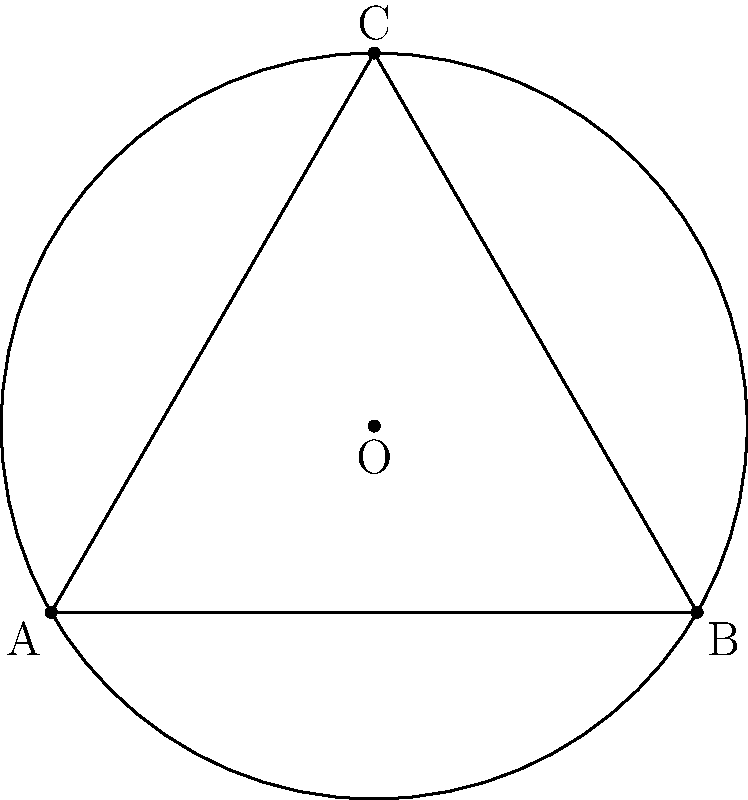In a non-Euclidean communal farming plot represented by the shape above, the triangle ABC is inscribed in a circle with center O. If the radius of the circle is 1.155 units and the side lengths of the triangle are AB = 2, BC = 2, and AC = 2, calculate the area of the shaded region (the area between the circle and the triangle) to the nearest hundredth of a square unit. To find the area of the shaded region, we need to:

1. Calculate the area of the circle:
   $$A_{circle} = \pi r^2 = \pi (1.155)^2 = 4.19 \text{ sq units}$$

2. Calculate the area of the triangle:
   In non-Euclidean geometry, the sum of angles in a triangle is less than 180°. We can use the formula:
   $$A_{triangle} = \pi R^2 - (\alpha + \beta + \gamma - \pi)R^2$$
   where R is the radius of the circumscribed circle, and α, β, γ are the angles of the triangle.

   For an equilateral triangle in this non-Euclidean space:
   $$A_{triangle} = \pi (1.155)^2 - (3\theta - \pi)(1.155)^2$$
   where θ is the angle at each vertex.

   We can find θ using the law of cosines in hyperbolic geometry:
   $$\cosh(\frac{2}{1.155}) = \frac{\cosh^2(\frac{2}{1.155})}{\sinh(\frac{2}{1.155})\cot(\frac{\theta}{2})}$$

   Solving this numerically gives θ ≈ 0.95 radians.

   Substituting back:
   $$A_{triangle} = 4.19 - (3(0.95) - \pi)(1.155)^2 = 3.14 \text{ sq units}$$

3. Calculate the difference:
   $$A_{shaded} = A_{circle} - A_{triangle} = 4.19 - 3.14 = 1.05 \text{ sq units}$$

Rounding to the nearest hundredth gives 1.05 square units.
Answer: 1.05 sq units 